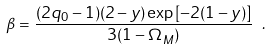<formula> <loc_0><loc_0><loc_500><loc_500>\beta = \frac { ( 2 q _ { 0 } - 1 ) ( 2 - y ) \exp { [ - 2 ( 1 - y ) ] } } { 3 ( 1 - \Omega _ { M } ) } \ .</formula> 